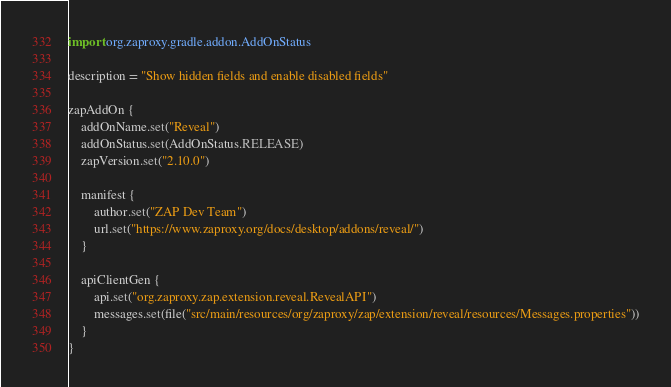<code> <loc_0><loc_0><loc_500><loc_500><_Kotlin_>import org.zaproxy.gradle.addon.AddOnStatus

description = "Show hidden fields and enable disabled fields"

zapAddOn {
    addOnName.set("Reveal")
    addOnStatus.set(AddOnStatus.RELEASE)
    zapVersion.set("2.10.0")

    manifest {
        author.set("ZAP Dev Team")
        url.set("https://www.zaproxy.org/docs/desktop/addons/reveal/")
    }

    apiClientGen {
        api.set("org.zaproxy.zap.extension.reveal.RevealAPI")
        messages.set(file("src/main/resources/org/zaproxy/zap/extension/reveal/resources/Messages.properties"))
    }
}
</code> 